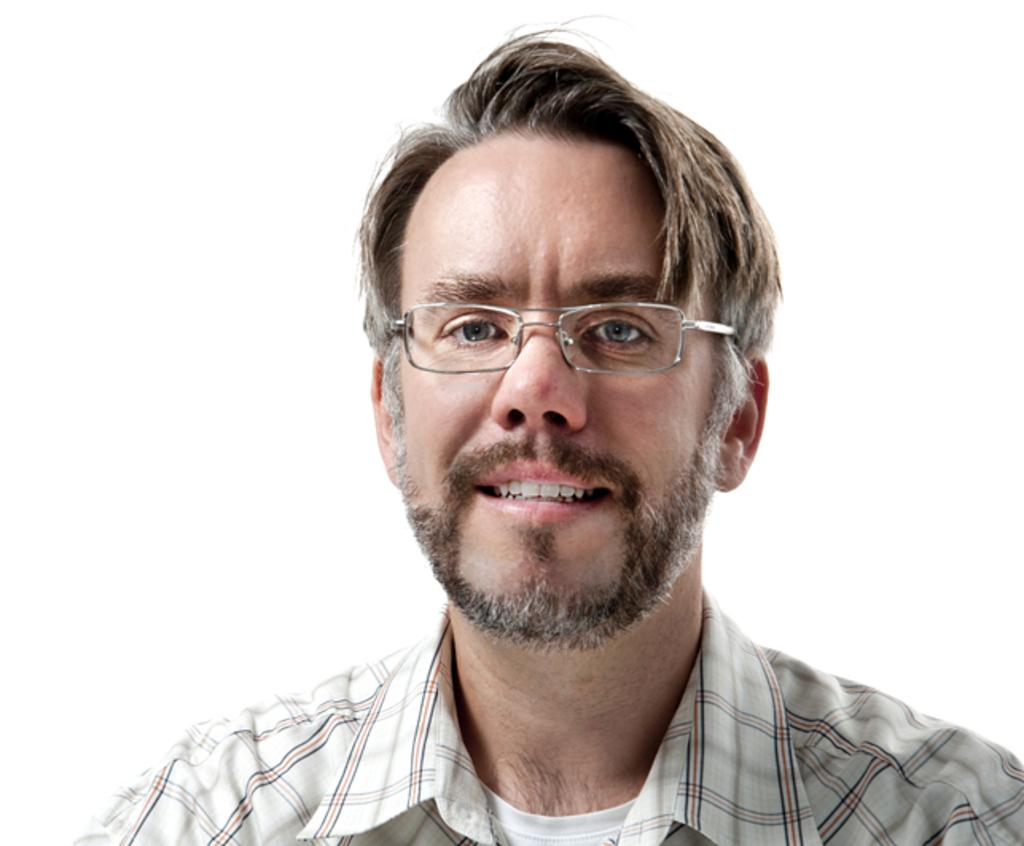What is present in the image? There is a person in the image. How is the person's expression in the image? The person is smiling. What type of carriage is the queen riding in the image? There is no carriage or queen present in the image; it only features a person who is smiling. 